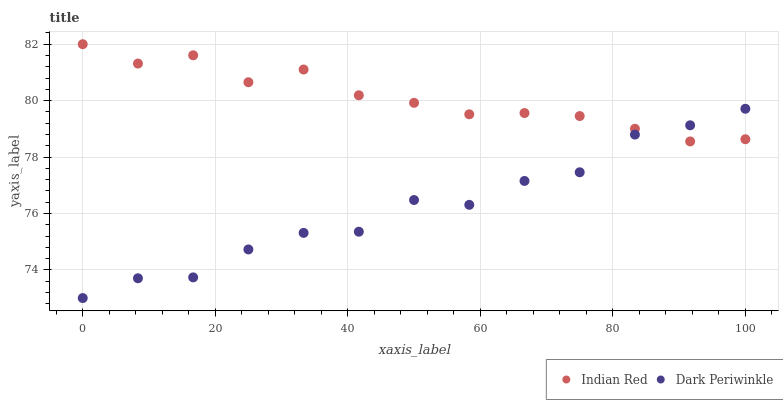Does Dark Periwinkle have the minimum area under the curve?
Answer yes or no. Yes. Does Indian Red have the maximum area under the curve?
Answer yes or no. Yes. Does Indian Red have the minimum area under the curve?
Answer yes or no. No. Is Indian Red the smoothest?
Answer yes or no. Yes. Is Dark Periwinkle the roughest?
Answer yes or no. Yes. Is Indian Red the roughest?
Answer yes or no. No. Does Dark Periwinkle have the lowest value?
Answer yes or no. Yes. Does Indian Red have the lowest value?
Answer yes or no. No. Does Indian Red have the highest value?
Answer yes or no. Yes. Does Dark Periwinkle intersect Indian Red?
Answer yes or no. Yes. Is Dark Periwinkle less than Indian Red?
Answer yes or no. No. Is Dark Periwinkle greater than Indian Red?
Answer yes or no. No. 